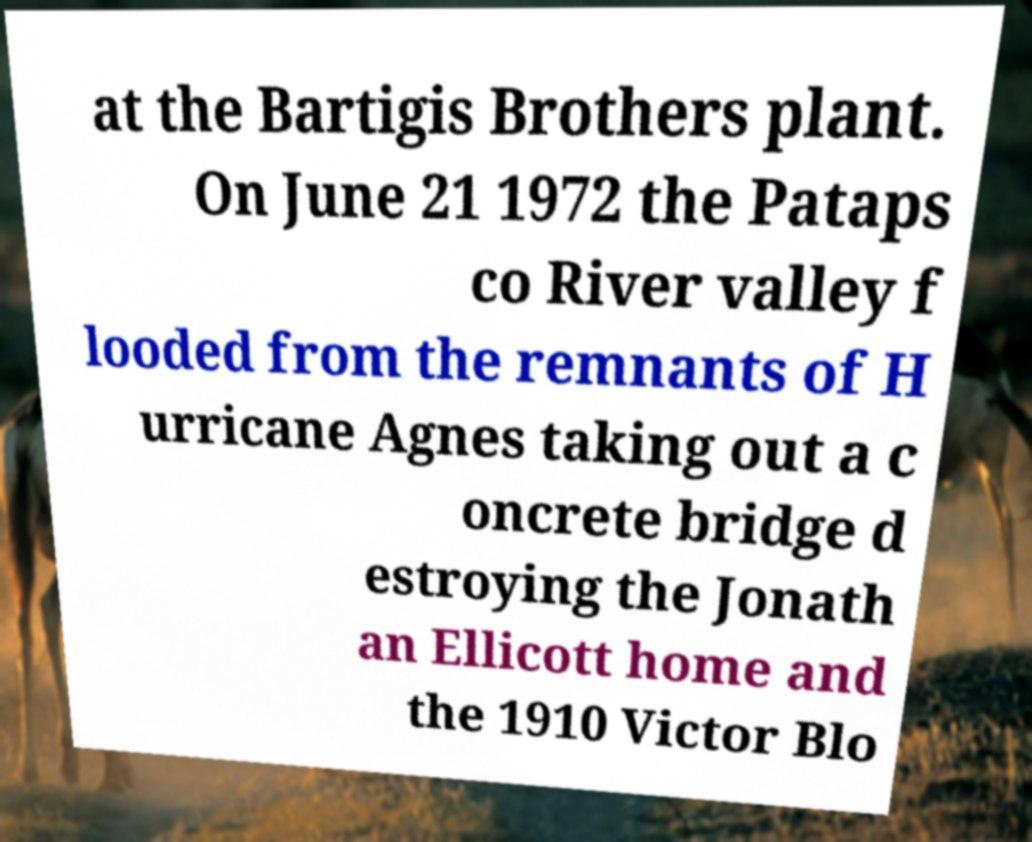Could you extract and type out the text from this image? at the Bartigis Brothers plant. On June 21 1972 the Pataps co River valley f looded from the remnants of H urricane Agnes taking out a c oncrete bridge d estroying the Jonath an Ellicott home and the 1910 Victor Blo 